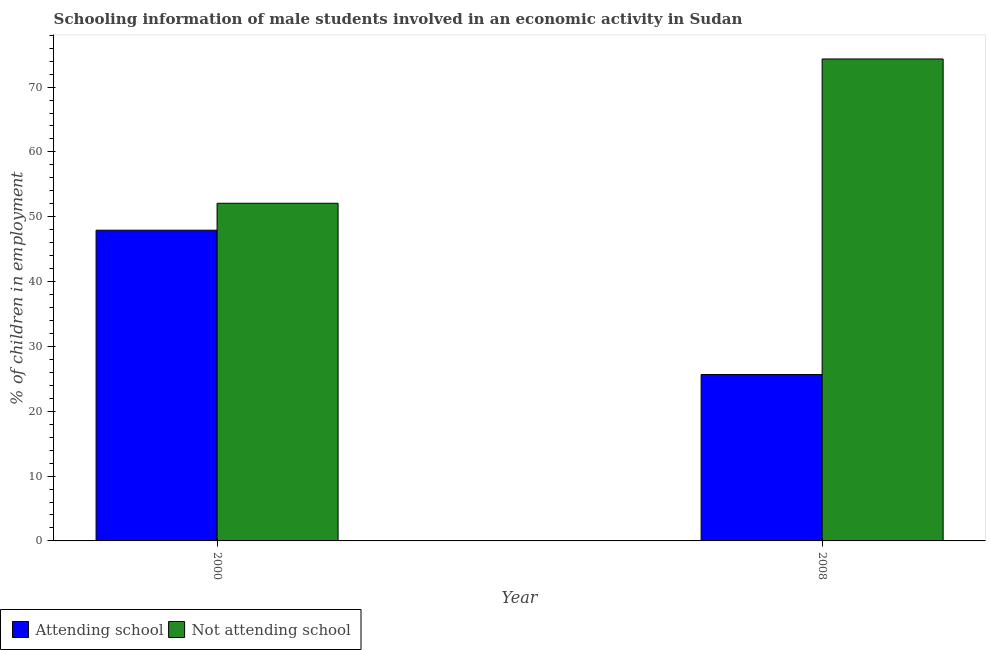How many different coloured bars are there?
Give a very brief answer. 2. Are the number of bars per tick equal to the number of legend labels?
Keep it short and to the point. Yes. Are the number of bars on each tick of the X-axis equal?
Make the answer very short. Yes. How many bars are there on the 1st tick from the left?
Give a very brief answer. 2. How many bars are there on the 1st tick from the right?
Offer a terse response. 2. What is the label of the 2nd group of bars from the left?
Provide a short and direct response. 2008. In how many cases, is the number of bars for a given year not equal to the number of legend labels?
Provide a succinct answer. 0. What is the percentage of employed males who are not attending school in 2008?
Your response must be concise. 74.33. Across all years, what is the maximum percentage of employed males who are not attending school?
Ensure brevity in your answer.  74.33. Across all years, what is the minimum percentage of employed males who are attending school?
Offer a terse response. 25.67. In which year was the percentage of employed males who are attending school minimum?
Your response must be concise. 2008. What is the total percentage of employed males who are attending school in the graph?
Your response must be concise. 73.59. What is the difference between the percentage of employed males who are attending school in 2000 and that in 2008?
Keep it short and to the point. 22.26. What is the difference between the percentage of employed males who are not attending school in 2008 and the percentage of employed males who are attending school in 2000?
Offer a very short reply. 22.26. What is the average percentage of employed males who are not attending school per year?
Offer a terse response. 63.21. What is the ratio of the percentage of employed males who are attending school in 2000 to that in 2008?
Make the answer very short. 1.87. Is the percentage of employed males who are attending school in 2000 less than that in 2008?
Your answer should be compact. No. What does the 1st bar from the left in 2008 represents?
Make the answer very short. Attending school. What does the 1st bar from the right in 2008 represents?
Your answer should be very brief. Not attending school. How many bars are there?
Your answer should be very brief. 4. How many years are there in the graph?
Your answer should be compact. 2. Are the values on the major ticks of Y-axis written in scientific E-notation?
Ensure brevity in your answer.  No. Does the graph contain grids?
Your answer should be compact. No. Where does the legend appear in the graph?
Provide a short and direct response. Bottom left. How many legend labels are there?
Ensure brevity in your answer.  2. How are the legend labels stacked?
Your response must be concise. Horizontal. What is the title of the graph?
Keep it short and to the point. Schooling information of male students involved in an economic activity in Sudan. Does "Private credit bureau" appear as one of the legend labels in the graph?
Offer a terse response. No. What is the label or title of the Y-axis?
Give a very brief answer. % of children in employment. What is the % of children in employment in Attending school in 2000?
Offer a very short reply. 47.92. What is the % of children in employment in Not attending school in 2000?
Your answer should be very brief. 52.08. What is the % of children in employment of Attending school in 2008?
Give a very brief answer. 25.67. What is the % of children in employment in Not attending school in 2008?
Make the answer very short. 74.33. Across all years, what is the maximum % of children in employment in Attending school?
Provide a succinct answer. 47.92. Across all years, what is the maximum % of children in employment in Not attending school?
Offer a terse response. 74.33. Across all years, what is the minimum % of children in employment in Attending school?
Offer a terse response. 25.67. Across all years, what is the minimum % of children in employment of Not attending school?
Keep it short and to the point. 52.08. What is the total % of children in employment of Attending school in the graph?
Make the answer very short. 73.59. What is the total % of children in employment of Not attending school in the graph?
Provide a succinct answer. 126.41. What is the difference between the % of children in employment in Attending school in 2000 and that in 2008?
Your answer should be compact. 22.26. What is the difference between the % of children in employment in Not attending school in 2000 and that in 2008?
Your response must be concise. -22.26. What is the difference between the % of children in employment in Attending school in 2000 and the % of children in employment in Not attending school in 2008?
Offer a terse response. -26.41. What is the average % of children in employment of Attending school per year?
Give a very brief answer. 36.79. What is the average % of children in employment of Not attending school per year?
Ensure brevity in your answer.  63.21. In the year 2000, what is the difference between the % of children in employment in Attending school and % of children in employment in Not attending school?
Make the answer very short. -4.16. In the year 2008, what is the difference between the % of children in employment of Attending school and % of children in employment of Not attending school?
Your response must be concise. -48.67. What is the ratio of the % of children in employment of Attending school in 2000 to that in 2008?
Ensure brevity in your answer.  1.87. What is the ratio of the % of children in employment in Not attending school in 2000 to that in 2008?
Provide a succinct answer. 0.7. What is the difference between the highest and the second highest % of children in employment in Attending school?
Offer a very short reply. 22.26. What is the difference between the highest and the second highest % of children in employment of Not attending school?
Your answer should be compact. 22.26. What is the difference between the highest and the lowest % of children in employment in Attending school?
Offer a terse response. 22.26. What is the difference between the highest and the lowest % of children in employment in Not attending school?
Make the answer very short. 22.26. 